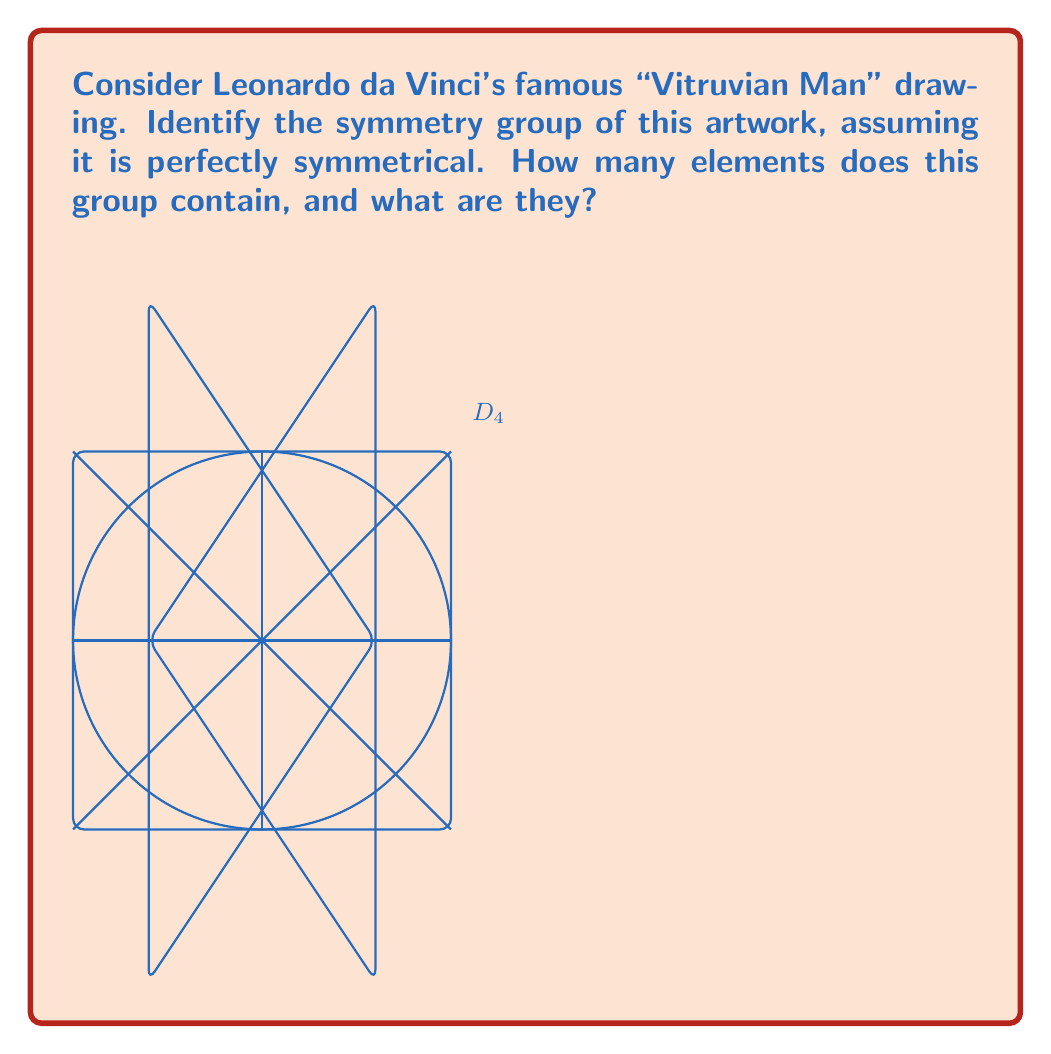Provide a solution to this math problem. To analyze the symmetry group of the Vitruvian Man, we need to consider all the symmetry operations that leave the figure unchanged. Let's break this down step-by-step:

1) The Vitruvian Man is inscribed in both a circle and a square, with arms and legs extended to touch both shapes.

2) The figure has two perpendicular lines of reflection symmetry:
   - Vertical line through the center
   - Horizontal line through the center

3) It also has rotational symmetry:
   - 90° rotation (quarter turn)
   - 180° rotation (half turn)
   - 270° rotation (three-quarter turn)
   - 360° rotation (full turn, which is equivalent to no rotation)

4) These symmetries form the dihedral group $D_4$, which is the symmetry group of a square.

5) The elements of $D_4$ are:
   - $e$: identity (no transformation)
   - $r$: 90° clockwise rotation
   - $r^2$: 180° rotation
   - $r^3$: 270° clockwise rotation (or 90° counterclockwise)
   - $h$: horizontal reflection
   - $v$: vertical reflection
   - $d$: diagonal reflection (top-left to bottom-right)
   - $d'$: diagonal reflection (top-right to bottom-left)

6) To count the elements, we can use the formula for $D_n$:
   $|D_n| = 2n$, where $n$ is the number of sides of the regular polygon (in this case, a square).

   $|D_4| = 2(4) = 8$

Therefore, the symmetry group of the Vitruvian Man (assuming perfect symmetry) is $D_4$, which contains 8 elements.
Answer: $D_4$; 8 elements: $\{e, r, r^2, r^3, h, v, d, d'\}$ 